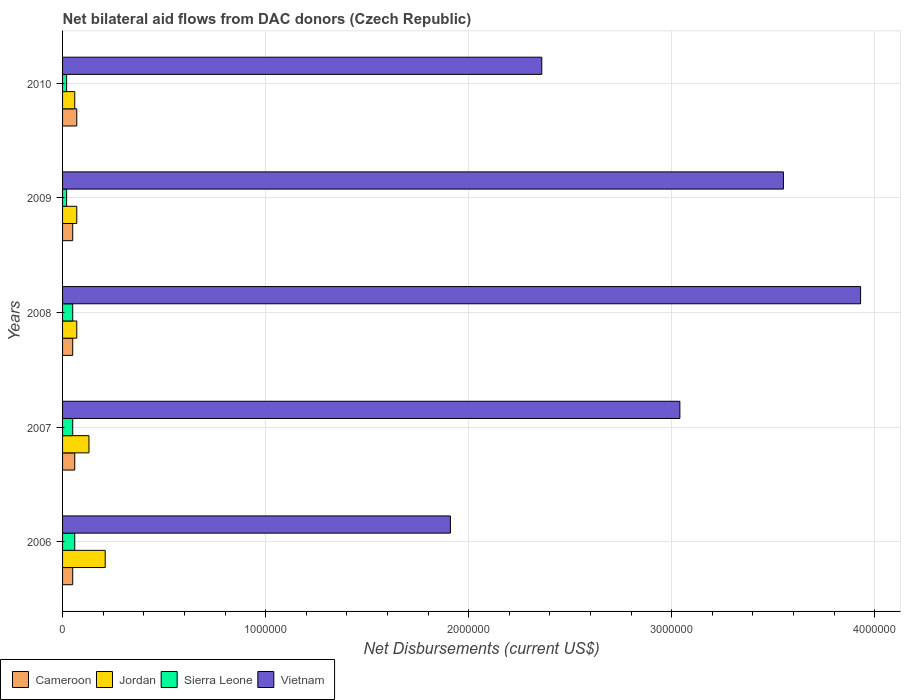How many different coloured bars are there?
Give a very brief answer. 4. Are the number of bars per tick equal to the number of legend labels?
Offer a very short reply. Yes. In how many cases, is the number of bars for a given year not equal to the number of legend labels?
Your answer should be very brief. 0. What is the net bilateral aid flows in Sierra Leone in 2010?
Your response must be concise. 2.00e+04. Across all years, what is the maximum net bilateral aid flows in Jordan?
Ensure brevity in your answer.  2.10e+05. Across all years, what is the minimum net bilateral aid flows in Sierra Leone?
Offer a terse response. 2.00e+04. In which year was the net bilateral aid flows in Sierra Leone maximum?
Give a very brief answer. 2006. In which year was the net bilateral aid flows in Jordan minimum?
Offer a very short reply. 2010. What is the total net bilateral aid flows in Cameroon in the graph?
Offer a very short reply. 2.80e+05. What is the difference between the net bilateral aid flows in Cameroon in 2007 and that in 2010?
Your answer should be very brief. -10000. What is the average net bilateral aid flows in Jordan per year?
Offer a terse response. 1.08e+05. In the year 2009, what is the difference between the net bilateral aid flows in Cameroon and net bilateral aid flows in Vietnam?
Give a very brief answer. -3.50e+06. What is the ratio of the net bilateral aid flows in Jordan in 2009 to that in 2010?
Provide a succinct answer. 1.17. Is the net bilateral aid flows in Jordan in 2006 less than that in 2010?
Your answer should be very brief. No. Is the difference between the net bilateral aid flows in Cameroon in 2007 and 2008 greater than the difference between the net bilateral aid flows in Vietnam in 2007 and 2008?
Your response must be concise. Yes. What is the difference between the highest and the lowest net bilateral aid flows in Jordan?
Give a very brief answer. 1.50e+05. In how many years, is the net bilateral aid flows in Vietnam greater than the average net bilateral aid flows in Vietnam taken over all years?
Provide a short and direct response. 3. Is the sum of the net bilateral aid flows in Cameroon in 2006 and 2010 greater than the maximum net bilateral aid flows in Sierra Leone across all years?
Your response must be concise. Yes. What does the 3rd bar from the top in 2008 represents?
Your response must be concise. Jordan. What does the 4th bar from the bottom in 2010 represents?
Your answer should be compact. Vietnam. Is it the case that in every year, the sum of the net bilateral aid flows in Jordan and net bilateral aid flows in Vietnam is greater than the net bilateral aid flows in Cameroon?
Make the answer very short. Yes. How many years are there in the graph?
Keep it short and to the point. 5. What is the difference between two consecutive major ticks on the X-axis?
Your answer should be very brief. 1.00e+06. Does the graph contain grids?
Offer a terse response. Yes. How many legend labels are there?
Provide a short and direct response. 4. What is the title of the graph?
Ensure brevity in your answer.  Net bilateral aid flows from DAC donors (Czech Republic). Does "Cayman Islands" appear as one of the legend labels in the graph?
Make the answer very short. No. What is the label or title of the X-axis?
Your answer should be compact. Net Disbursements (current US$). What is the label or title of the Y-axis?
Your response must be concise. Years. What is the Net Disbursements (current US$) in Cameroon in 2006?
Your answer should be very brief. 5.00e+04. What is the Net Disbursements (current US$) in Jordan in 2006?
Provide a short and direct response. 2.10e+05. What is the Net Disbursements (current US$) of Vietnam in 2006?
Keep it short and to the point. 1.91e+06. What is the Net Disbursements (current US$) in Sierra Leone in 2007?
Make the answer very short. 5.00e+04. What is the Net Disbursements (current US$) in Vietnam in 2007?
Make the answer very short. 3.04e+06. What is the Net Disbursements (current US$) in Cameroon in 2008?
Your response must be concise. 5.00e+04. What is the Net Disbursements (current US$) of Jordan in 2008?
Your answer should be compact. 7.00e+04. What is the Net Disbursements (current US$) in Sierra Leone in 2008?
Provide a succinct answer. 5.00e+04. What is the Net Disbursements (current US$) of Vietnam in 2008?
Provide a succinct answer. 3.93e+06. What is the Net Disbursements (current US$) of Cameroon in 2009?
Your answer should be very brief. 5.00e+04. What is the Net Disbursements (current US$) of Jordan in 2009?
Your answer should be compact. 7.00e+04. What is the Net Disbursements (current US$) of Sierra Leone in 2009?
Provide a succinct answer. 2.00e+04. What is the Net Disbursements (current US$) of Vietnam in 2009?
Offer a terse response. 3.55e+06. What is the Net Disbursements (current US$) of Vietnam in 2010?
Your answer should be very brief. 2.36e+06. Across all years, what is the maximum Net Disbursements (current US$) in Jordan?
Your answer should be very brief. 2.10e+05. Across all years, what is the maximum Net Disbursements (current US$) in Vietnam?
Your response must be concise. 3.93e+06. Across all years, what is the minimum Net Disbursements (current US$) of Cameroon?
Your answer should be very brief. 5.00e+04. Across all years, what is the minimum Net Disbursements (current US$) of Sierra Leone?
Give a very brief answer. 2.00e+04. Across all years, what is the minimum Net Disbursements (current US$) in Vietnam?
Ensure brevity in your answer.  1.91e+06. What is the total Net Disbursements (current US$) of Jordan in the graph?
Ensure brevity in your answer.  5.40e+05. What is the total Net Disbursements (current US$) in Vietnam in the graph?
Provide a short and direct response. 1.48e+07. What is the difference between the Net Disbursements (current US$) in Cameroon in 2006 and that in 2007?
Provide a short and direct response. -10000. What is the difference between the Net Disbursements (current US$) of Vietnam in 2006 and that in 2007?
Make the answer very short. -1.13e+06. What is the difference between the Net Disbursements (current US$) of Cameroon in 2006 and that in 2008?
Provide a short and direct response. 0. What is the difference between the Net Disbursements (current US$) in Jordan in 2006 and that in 2008?
Provide a short and direct response. 1.40e+05. What is the difference between the Net Disbursements (current US$) of Sierra Leone in 2006 and that in 2008?
Make the answer very short. 10000. What is the difference between the Net Disbursements (current US$) of Vietnam in 2006 and that in 2008?
Provide a short and direct response. -2.02e+06. What is the difference between the Net Disbursements (current US$) in Cameroon in 2006 and that in 2009?
Your response must be concise. 0. What is the difference between the Net Disbursements (current US$) of Sierra Leone in 2006 and that in 2009?
Your answer should be very brief. 4.00e+04. What is the difference between the Net Disbursements (current US$) of Vietnam in 2006 and that in 2009?
Your answer should be compact. -1.64e+06. What is the difference between the Net Disbursements (current US$) of Cameroon in 2006 and that in 2010?
Offer a very short reply. -2.00e+04. What is the difference between the Net Disbursements (current US$) of Sierra Leone in 2006 and that in 2010?
Offer a terse response. 4.00e+04. What is the difference between the Net Disbursements (current US$) in Vietnam in 2006 and that in 2010?
Keep it short and to the point. -4.50e+05. What is the difference between the Net Disbursements (current US$) of Cameroon in 2007 and that in 2008?
Provide a succinct answer. 10000. What is the difference between the Net Disbursements (current US$) in Vietnam in 2007 and that in 2008?
Keep it short and to the point. -8.90e+05. What is the difference between the Net Disbursements (current US$) in Jordan in 2007 and that in 2009?
Offer a very short reply. 6.00e+04. What is the difference between the Net Disbursements (current US$) in Sierra Leone in 2007 and that in 2009?
Your answer should be very brief. 3.00e+04. What is the difference between the Net Disbursements (current US$) in Vietnam in 2007 and that in 2009?
Your response must be concise. -5.10e+05. What is the difference between the Net Disbursements (current US$) in Vietnam in 2007 and that in 2010?
Your response must be concise. 6.80e+05. What is the difference between the Net Disbursements (current US$) in Sierra Leone in 2008 and that in 2009?
Keep it short and to the point. 3.00e+04. What is the difference between the Net Disbursements (current US$) of Jordan in 2008 and that in 2010?
Make the answer very short. 10000. What is the difference between the Net Disbursements (current US$) in Vietnam in 2008 and that in 2010?
Provide a short and direct response. 1.57e+06. What is the difference between the Net Disbursements (current US$) in Vietnam in 2009 and that in 2010?
Ensure brevity in your answer.  1.19e+06. What is the difference between the Net Disbursements (current US$) of Cameroon in 2006 and the Net Disbursements (current US$) of Jordan in 2007?
Your answer should be compact. -8.00e+04. What is the difference between the Net Disbursements (current US$) of Cameroon in 2006 and the Net Disbursements (current US$) of Vietnam in 2007?
Ensure brevity in your answer.  -2.99e+06. What is the difference between the Net Disbursements (current US$) in Jordan in 2006 and the Net Disbursements (current US$) in Vietnam in 2007?
Make the answer very short. -2.83e+06. What is the difference between the Net Disbursements (current US$) of Sierra Leone in 2006 and the Net Disbursements (current US$) of Vietnam in 2007?
Give a very brief answer. -2.98e+06. What is the difference between the Net Disbursements (current US$) in Cameroon in 2006 and the Net Disbursements (current US$) in Vietnam in 2008?
Keep it short and to the point. -3.88e+06. What is the difference between the Net Disbursements (current US$) in Jordan in 2006 and the Net Disbursements (current US$) in Sierra Leone in 2008?
Your answer should be compact. 1.60e+05. What is the difference between the Net Disbursements (current US$) in Jordan in 2006 and the Net Disbursements (current US$) in Vietnam in 2008?
Provide a short and direct response. -3.72e+06. What is the difference between the Net Disbursements (current US$) of Sierra Leone in 2006 and the Net Disbursements (current US$) of Vietnam in 2008?
Ensure brevity in your answer.  -3.87e+06. What is the difference between the Net Disbursements (current US$) in Cameroon in 2006 and the Net Disbursements (current US$) in Jordan in 2009?
Provide a short and direct response. -2.00e+04. What is the difference between the Net Disbursements (current US$) in Cameroon in 2006 and the Net Disbursements (current US$) in Sierra Leone in 2009?
Give a very brief answer. 3.00e+04. What is the difference between the Net Disbursements (current US$) of Cameroon in 2006 and the Net Disbursements (current US$) of Vietnam in 2009?
Make the answer very short. -3.50e+06. What is the difference between the Net Disbursements (current US$) of Jordan in 2006 and the Net Disbursements (current US$) of Sierra Leone in 2009?
Ensure brevity in your answer.  1.90e+05. What is the difference between the Net Disbursements (current US$) of Jordan in 2006 and the Net Disbursements (current US$) of Vietnam in 2009?
Provide a succinct answer. -3.34e+06. What is the difference between the Net Disbursements (current US$) of Sierra Leone in 2006 and the Net Disbursements (current US$) of Vietnam in 2009?
Offer a very short reply. -3.49e+06. What is the difference between the Net Disbursements (current US$) in Cameroon in 2006 and the Net Disbursements (current US$) in Sierra Leone in 2010?
Keep it short and to the point. 3.00e+04. What is the difference between the Net Disbursements (current US$) of Cameroon in 2006 and the Net Disbursements (current US$) of Vietnam in 2010?
Provide a short and direct response. -2.31e+06. What is the difference between the Net Disbursements (current US$) in Jordan in 2006 and the Net Disbursements (current US$) in Vietnam in 2010?
Your response must be concise. -2.15e+06. What is the difference between the Net Disbursements (current US$) of Sierra Leone in 2006 and the Net Disbursements (current US$) of Vietnam in 2010?
Make the answer very short. -2.30e+06. What is the difference between the Net Disbursements (current US$) of Cameroon in 2007 and the Net Disbursements (current US$) of Jordan in 2008?
Your response must be concise. -10000. What is the difference between the Net Disbursements (current US$) in Cameroon in 2007 and the Net Disbursements (current US$) in Vietnam in 2008?
Keep it short and to the point. -3.87e+06. What is the difference between the Net Disbursements (current US$) of Jordan in 2007 and the Net Disbursements (current US$) of Sierra Leone in 2008?
Keep it short and to the point. 8.00e+04. What is the difference between the Net Disbursements (current US$) in Jordan in 2007 and the Net Disbursements (current US$) in Vietnam in 2008?
Provide a short and direct response. -3.80e+06. What is the difference between the Net Disbursements (current US$) in Sierra Leone in 2007 and the Net Disbursements (current US$) in Vietnam in 2008?
Provide a short and direct response. -3.88e+06. What is the difference between the Net Disbursements (current US$) of Cameroon in 2007 and the Net Disbursements (current US$) of Jordan in 2009?
Provide a succinct answer. -10000. What is the difference between the Net Disbursements (current US$) of Cameroon in 2007 and the Net Disbursements (current US$) of Sierra Leone in 2009?
Keep it short and to the point. 4.00e+04. What is the difference between the Net Disbursements (current US$) of Cameroon in 2007 and the Net Disbursements (current US$) of Vietnam in 2009?
Ensure brevity in your answer.  -3.49e+06. What is the difference between the Net Disbursements (current US$) in Jordan in 2007 and the Net Disbursements (current US$) in Vietnam in 2009?
Your answer should be compact. -3.42e+06. What is the difference between the Net Disbursements (current US$) in Sierra Leone in 2007 and the Net Disbursements (current US$) in Vietnam in 2009?
Provide a succinct answer. -3.50e+06. What is the difference between the Net Disbursements (current US$) of Cameroon in 2007 and the Net Disbursements (current US$) of Sierra Leone in 2010?
Offer a very short reply. 4.00e+04. What is the difference between the Net Disbursements (current US$) in Cameroon in 2007 and the Net Disbursements (current US$) in Vietnam in 2010?
Make the answer very short. -2.30e+06. What is the difference between the Net Disbursements (current US$) of Jordan in 2007 and the Net Disbursements (current US$) of Sierra Leone in 2010?
Provide a short and direct response. 1.10e+05. What is the difference between the Net Disbursements (current US$) in Jordan in 2007 and the Net Disbursements (current US$) in Vietnam in 2010?
Offer a terse response. -2.23e+06. What is the difference between the Net Disbursements (current US$) in Sierra Leone in 2007 and the Net Disbursements (current US$) in Vietnam in 2010?
Offer a very short reply. -2.31e+06. What is the difference between the Net Disbursements (current US$) of Cameroon in 2008 and the Net Disbursements (current US$) of Jordan in 2009?
Your answer should be very brief. -2.00e+04. What is the difference between the Net Disbursements (current US$) of Cameroon in 2008 and the Net Disbursements (current US$) of Vietnam in 2009?
Offer a terse response. -3.50e+06. What is the difference between the Net Disbursements (current US$) of Jordan in 2008 and the Net Disbursements (current US$) of Vietnam in 2009?
Ensure brevity in your answer.  -3.48e+06. What is the difference between the Net Disbursements (current US$) of Sierra Leone in 2008 and the Net Disbursements (current US$) of Vietnam in 2009?
Offer a very short reply. -3.50e+06. What is the difference between the Net Disbursements (current US$) of Cameroon in 2008 and the Net Disbursements (current US$) of Jordan in 2010?
Offer a very short reply. -10000. What is the difference between the Net Disbursements (current US$) in Cameroon in 2008 and the Net Disbursements (current US$) in Vietnam in 2010?
Give a very brief answer. -2.31e+06. What is the difference between the Net Disbursements (current US$) in Jordan in 2008 and the Net Disbursements (current US$) in Sierra Leone in 2010?
Offer a terse response. 5.00e+04. What is the difference between the Net Disbursements (current US$) in Jordan in 2008 and the Net Disbursements (current US$) in Vietnam in 2010?
Provide a succinct answer. -2.29e+06. What is the difference between the Net Disbursements (current US$) of Sierra Leone in 2008 and the Net Disbursements (current US$) of Vietnam in 2010?
Your answer should be compact. -2.31e+06. What is the difference between the Net Disbursements (current US$) of Cameroon in 2009 and the Net Disbursements (current US$) of Jordan in 2010?
Ensure brevity in your answer.  -10000. What is the difference between the Net Disbursements (current US$) of Cameroon in 2009 and the Net Disbursements (current US$) of Sierra Leone in 2010?
Provide a succinct answer. 3.00e+04. What is the difference between the Net Disbursements (current US$) in Cameroon in 2009 and the Net Disbursements (current US$) in Vietnam in 2010?
Give a very brief answer. -2.31e+06. What is the difference between the Net Disbursements (current US$) of Jordan in 2009 and the Net Disbursements (current US$) of Vietnam in 2010?
Make the answer very short. -2.29e+06. What is the difference between the Net Disbursements (current US$) of Sierra Leone in 2009 and the Net Disbursements (current US$) of Vietnam in 2010?
Your response must be concise. -2.34e+06. What is the average Net Disbursements (current US$) of Cameroon per year?
Your answer should be very brief. 5.60e+04. What is the average Net Disbursements (current US$) of Jordan per year?
Provide a succinct answer. 1.08e+05. What is the average Net Disbursements (current US$) in Sierra Leone per year?
Give a very brief answer. 4.00e+04. What is the average Net Disbursements (current US$) of Vietnam per year?
Keep it short and to the point. 2.96e+06. In the year 2006, what is the difference between the Net Disbursements (current US$) in Cameroon and Net Disbursements (current US$) in Jordan?
Provide a short and direct response. -1.60e+05. In the year 2006, what is the difference between the Net Disbursements (current US$) of Cameroon and Net Disbursements (current US$) of Sierra Leone?
Make the answer very short. -10000. In the year 2006, what is the difference between the Net Disbursements (current US$) of Cameroon and Net Disbursements (current US$) of Vietnam?
Keep it short and to the point. -1.86e+06. In the year 2006, what is the difference between the Net Disbursements (current US$) of Jordan and Net Disbursements (current US$) of Vietnam?
Keep it short and to the point. -1.70e+06. In the year 2006, what is the difference between the Net Disbursements (current US$) of Sierra Leone and Net Disbursements (current US$) of Vietnam?
Provide a succinct answer. -1.85e+06. In the year 2007, what is the difference between the Net Disbursements (current US$) of Cameroon and Net Disbursements (current US$) of Jordan?
Your answer should be compact. -7.00e+04. In the year 2007, what is the difference between the Net Disbursements (current US$) of Cameroon and Net Disbursements (current US$) of Sierra Leone?
Offer a very short reply. 10000. In the year 2007, what is the difference between the Net Disbursements (current US$) of Cameroon and Net Disbursements (current US$) of Vietnam?
Your response must be concise. -2.98e+06. In the year 2007, what is the difference between the Net Disbursements (current US$) of Jordan and Net Disbursements (current US$) of Vietnam?
Provide a succinct answer. -2.91e+06. In the year 2007, what is the difference between the Net Disbursements (current US$) of Sierra Leone and Net Disbursements (current US$) of Vietnam?
Offer a very short reply. -2.99e+06. In the year 2008, what is the difference between the Net Disbursements (current US$) of Cameroon and Net Disbursements (current US$) of Sierra Leone?
Provide a short and direct response. 0. In the year 2008, what is the difference between the Net Disbursements (current US$) of Cameroon and Net Disbursements (current US$) of Vietnam?
Your answer should be compact. -3.88e+06. In the year 2008, what is the difference between the Net Disbursements (current US$) in Jordan and Net Disbursements (current US$) in Vietnam?
Your response must be concise. -3.86e+06. In the year 2008, what is the difference between the Net Disbursements (current US$) of Sierra Leone and Net Disbursements (current US$) of Vietnam?
Keep it short and to the point. -3.88e+06. In the year 2009, what is the difference between the Net Disbursements (current US$) in Cameroon and Net Disbursements (current US$) in Jordan?
Make the answer very short. -2.00e+04. In the year 2009, what is the difference between the Net Disbursements (current US$) of Cameroon and Net Disbursements (current US$) of Sierra Leone?
Give a very brief answer. 3.00e+04. In the year 2009, what is the difference between the Net Disbursements (current US$) in Cameroon and Net Disbursements (current US$) in Vietnam?
Ensure brevity in your answer.  -3.50e+06. In the year 2009, what is the difference between the Net Disbursements (current US$) in Jordan and Net Disbursements (current US$) in Vietnam?
Keep it short and to the point. -3.48e+06. In the year 2009, what is the difference between the Net Disbursements (current US$) in Sierra Leone and Net Disbursements (current US$) in Vietnam?
Keep it short and to the point. -3.53e+06. In the year 2010, what is the difference between the Net Disbursements (current US$) of Cameroon and Net Disbursements (current US$) of Jordan?
Offer a very short reply. 10000. In the year 2010, what is the difference between the Net Disbursements (current US$) of Cameroon and Net Disbursements (current US$) of Sierra Leone?
Your answer should be compact. 5.00e+04. In the year 2010, what is the difference between the Net Disbursements (current US$) in Cameroon and Net Disbursements (current US$) in Vietnam?
Your answer should be compact. -2.29e+06. In the year 2010, what is the difference between the Net Disbursements (current US$) of Jordan and Net Disbursements (current US$) of Sierra Leone?
Offer a terse response. 4.00e+04. In the year 2010, what is the difference between the Net Disbursements (current US$) in Jordan and Net Disbursements (current US$) in Vietnam?
Your answer should be very brief. -2.30e+06. In the year 2010, what is the difference between the Net Disbursements (current US$) in Sierra Leone and Net Disbursements (current US$) in Vietnam?
Provide a short and direct response. -2.34e+06. What is the ratio of the Net Disbursements (current US$) in Jordan in 2006 to that in 2007?
Make the answer very short. 1.62. What is the ratio of the Net Disbursements (current US$) in Sierra Leone in 2006 to that in 2007?
Provide a short and direct response. 1.2. What is the ratio of the Net Disbursements (current US$) of Vietnam in 2006 to that in 2007?
Offer a very short reply. 0.63. What is the ratio of the Net Disbursements (current US$) in Cameroon in 2006 to that in 2008?
Provide a short and direct response. 1. What is the ratio of the Net Disbursements (current US$) of Sierra Leone in 2006 to that in 2008?
Provide a short and direct response. 1.2. What is the ratio of the Net Disbursements (current US$) in Vietnam in 2006 to that in 2008?
Your answer should be very brief. 0.49. What is the ratio of the Net Disbursements (current US$) in Jordan in 2006 to that in 2009?
Ensure brevity in your answer.  3. What is the ratio of the Net Disbursements (current US$) in Sierra Leone in 2006 to that in 2009?
Offer a very short reply. 3. What is the ratio of the Net Disbursements (current US$) in Vietnam in 2006 to that in 2009?
Offer a very short reply. 0.54. What is the ratio of the Net Disbursements (current US$) in Cameroon in 2006 to that in 2010?
Make the answer very short. 0.71. What is the ratio of the Net Disbursements (current US$) in Sierra Leone in 2006 to that in 2010?
Your response must be concise. 3. What is the ratio of the Net Disbursements (current US$) of Vietnam in 2006 to that in 2010?
Offer a very short reply. 0.81. What is the ratio of the Net Disbursements (current US$) in Cameroon in 2007 to that in 2008?
Ensure brevity in your answer.  1.2. What is the ratio of the Net Disbursements (current US$) of Jordan in 2007 to that in 2008?
Offer a very short reply. 1.86. What is the ratio of the Net Disbursements (current US$) of Vietnam in 2007 to that in 2008?
Provide a succinct answer. 0.77. What is the ratio of the Net Disbursements (current US$) in Cameroon in 2007 to that in 2009?
Offer a terse response. 1.2. What is the ratio of the Net Disbursements (current US$) in Jordan in 2007 to that in 2009?
Keep it short and to the point. 1.86. What is the ratio of the Net Disbursements (current US$) in Vietnam in 2007 to that in 2009?
Keep it short and to the point. 0.86. What is the ratio of the Net Disbursements (current US$) of Jordan in 2007 to that in 2010?
Ensure brevity in your answer.  2.17. What is the ratio of the Net Disbursements (current US$) in Vietnam in 2007 to that in 2010?
Keep it short and to the point. 1.29. What is the ratio of the Net Disbursements (current US$) of Cameroon in 2008 to that in 2009?
Offer a terse response. 1. What is the ratio of the Net Disbursements (current US$) in Jordan in 2008 to that in 2009?
Offer a very short reply. 1. What is the ratio of the Net Disbursements (current US$) of Sierra Leone in 2008 to that in 2009?
Ensure brevity in your answer.  2.5. What is the ratio of the Net Disbursements (current US$) in Vietnam in 2008 to that in 2009?
Make the answer very short. 1.11. What is the ratio of the Net Disbursements (current US$) of Cameroon in 2008 to that in 2010?
Offer a very short reply. 0.71. What is the ratio of the Net Disbursements (current US$) in Jordan in 2008 to that in 2010?
Your answer should be very brief. 1.17. What is the ratio of the Net Disbursements (current US$) of Sierra Leone in 2008 to that in 2010?
Your answer should be very brief. 2.5. What is the ratio of the Net Disbursements (current US$) of Vietnam in 2008 to that in 2010?
Keep it short and to the point. 1.67. What is the ratio of the Net Disbursements (current US$) of Sierra Leone in 2009 to that in 2010?
Offer a terse response. 1. What is the ratio of the Net Disbursements (current US$) in Vietnam in 2009 to that in 2010?
Your response must be concise. 1.5. What is the difference between the highest and the second highest Net Disbursements (current US$) of Vietnam?
Make the answer very short. 3.80e+05. What is the difference between the highest and the lowest Net Disbursements (current US$) of Cameroon?
Your answer should be very brief. 2.00e+04. What is the difference between the highest and the lowest Net Disbursements (current US$) of Jordan?
Make the answer very short. 1.50e+05. What is the difference between the highest and the lowest Net Disbursements (current US$) of Vietnam?
Offer a terse response. 2.02e+06. 